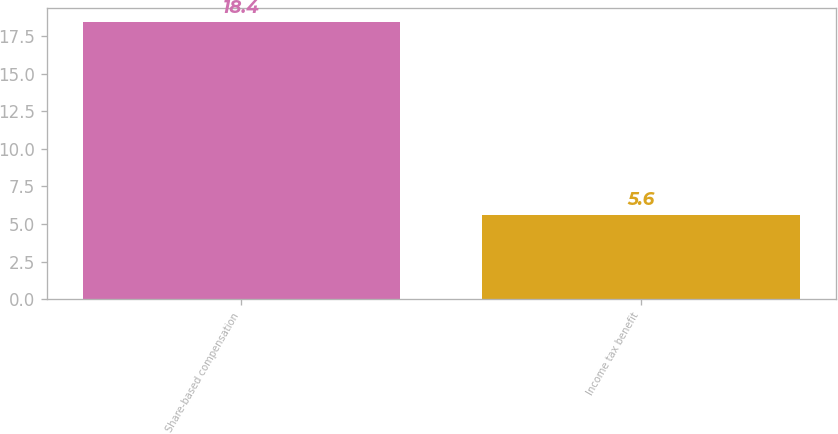<chart> <loc_0><loc_0><loc_500><loc_500><bar_chart><fcel>Share-based compensation<fcel>Income tax benefit<nl><fcel>18.4<fcel>5.6<nl></chart> 